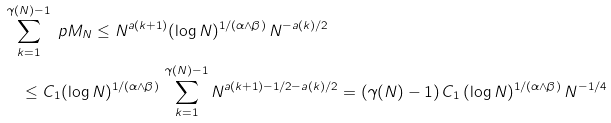<formula> <loc_0><loc_0><loc_500><loc_500>& \sum _ { k = 1 } ^ { \gamma ( N ) - 1 } \ p { M _ { N } \leq N ^ { a ( k + 1 ) } } ( \log N ) ^ { 1 / ( \alpha \wedge \beta ) } \, N ^ { - a ( k ) / 2 } \\ & \quad \leq C _ { 1 } ( \log N ) ^ { 1 / ( \alpha \wedge \beta ) } \, \sum _ { k = 1 } ^ { \gamma ( N ) - 1 } N ^ { a ( k + 1 ) - 1 / 2 - a ( k ) / 2 } = ( \gamma ( N ) - 1 ) \, C _ { 1 } \, ( \log N ) ^ { 1 / ( \alpha \wedge \beta ) } \, N ^ { - 1 / 4 }</formula> 